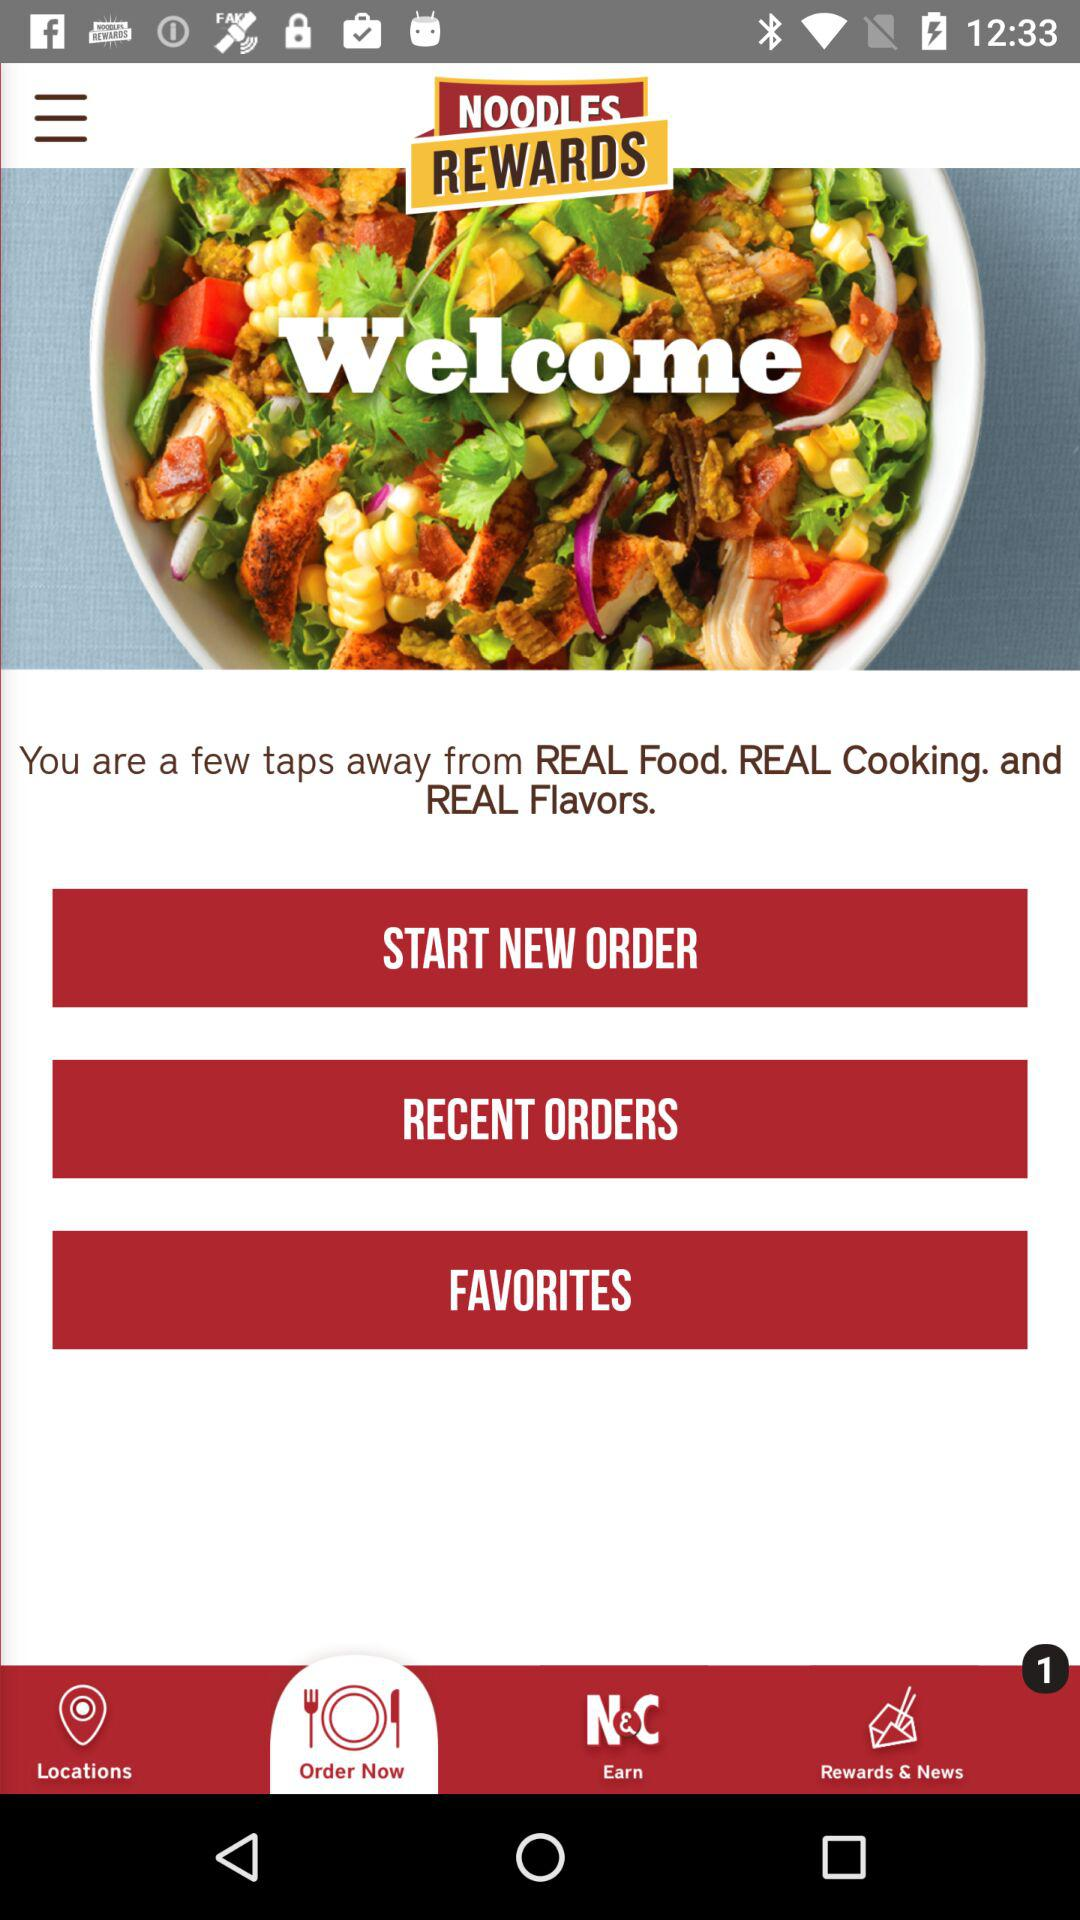Which tab am I on? You are on the tab "Order Now". 